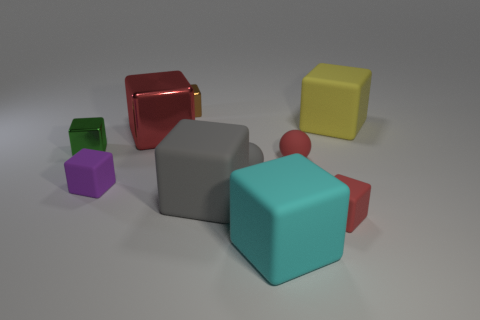Subtract all red balls. How many red blocks are left? 2 Subtract all matte blocks. How many blocks are left? 3 Subtract all green cubes. How many cubes are left? 7 Subtract 5 blocks. How many blocks are left? 3 Subtract all balls. How many objects are left? 8 Subtract all gray blocks. Subtract all purple cylinders. How many blocks are left? 7 Add 2 big cyan matte objects. How many big cyan matte objects exist? 3 Subtract 0 purple cylinders. How many objects are left? 10 Subtract all small cyan matte spheres. Subtract all yellow matte cubes. How many objects are left? 9 Add 3 matte things. How many matte things are left? 10 